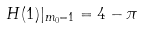<formula> <loc_0><loc_0><loc_500><loc_500>H ( 1 ) | _ { m _ { 0 } = 1 } = 4 - \pi</formula> 